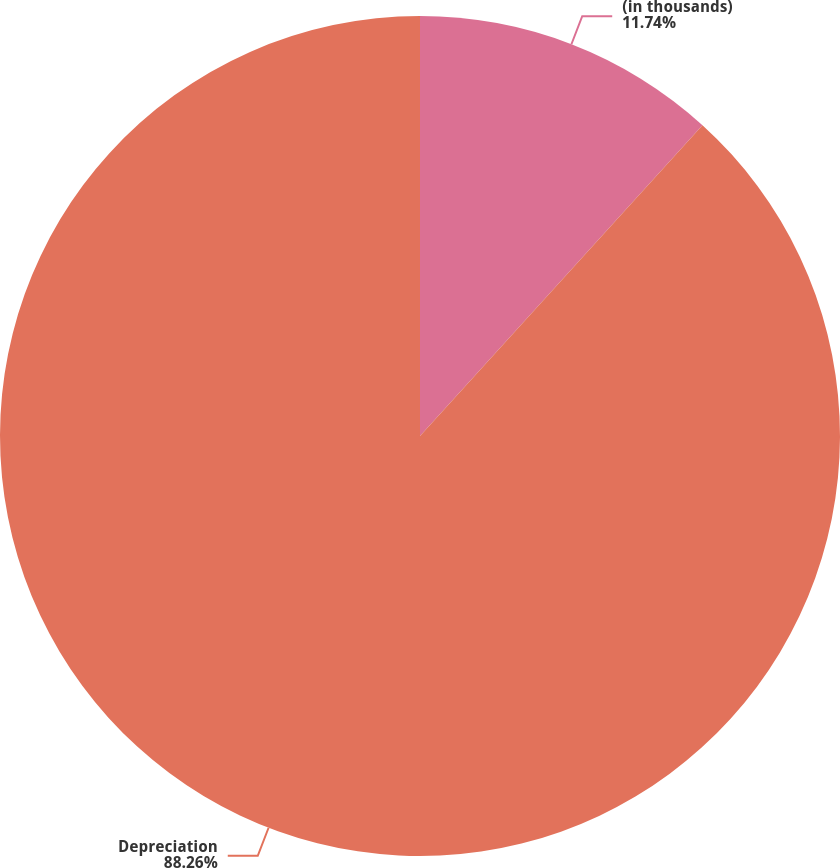<chart> <loc_0><loc_0><loc_500><loc_500><pie_chart><fcel>(in thousands)<fcel>Depreciation<nl><fcel>11.74%<fcel>88.26%<nl></chart> 